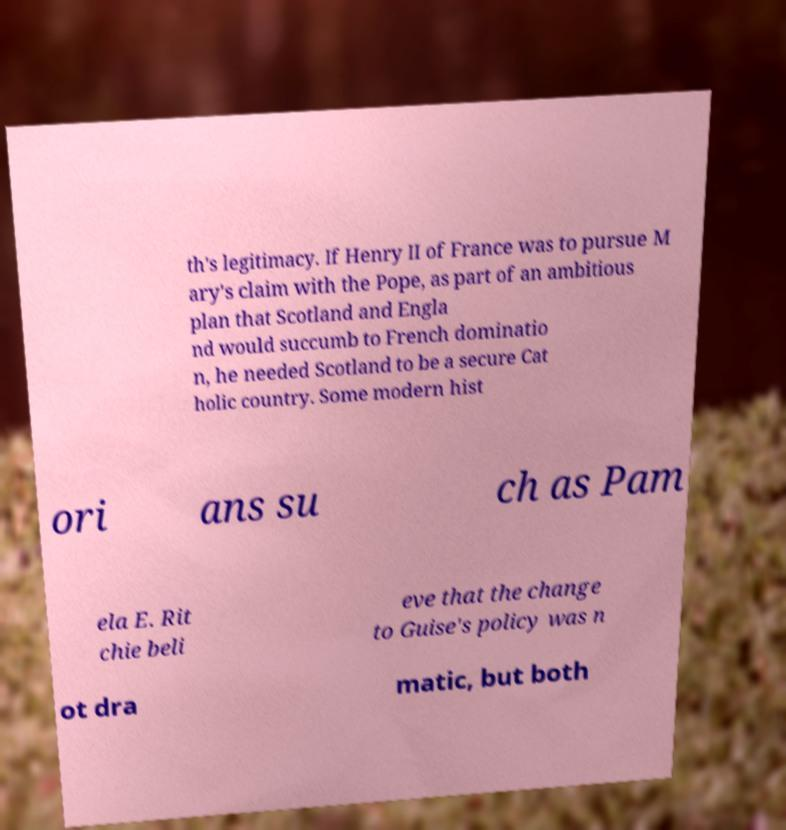Please identify and transcribe the text found in this image. th's legitimacy. If Henry II of France was to pursue M ary's claim with the Pope, as part of an ambitious plan that Scotland and Engla nd would succumb to French dominatio n, he needed Scotland to be a secure Cat holic country. Some modern hist ori ans su ch as Pam ela E. Rit chie beli eve that the change to Guise's policy was n ot dra matic, but both 